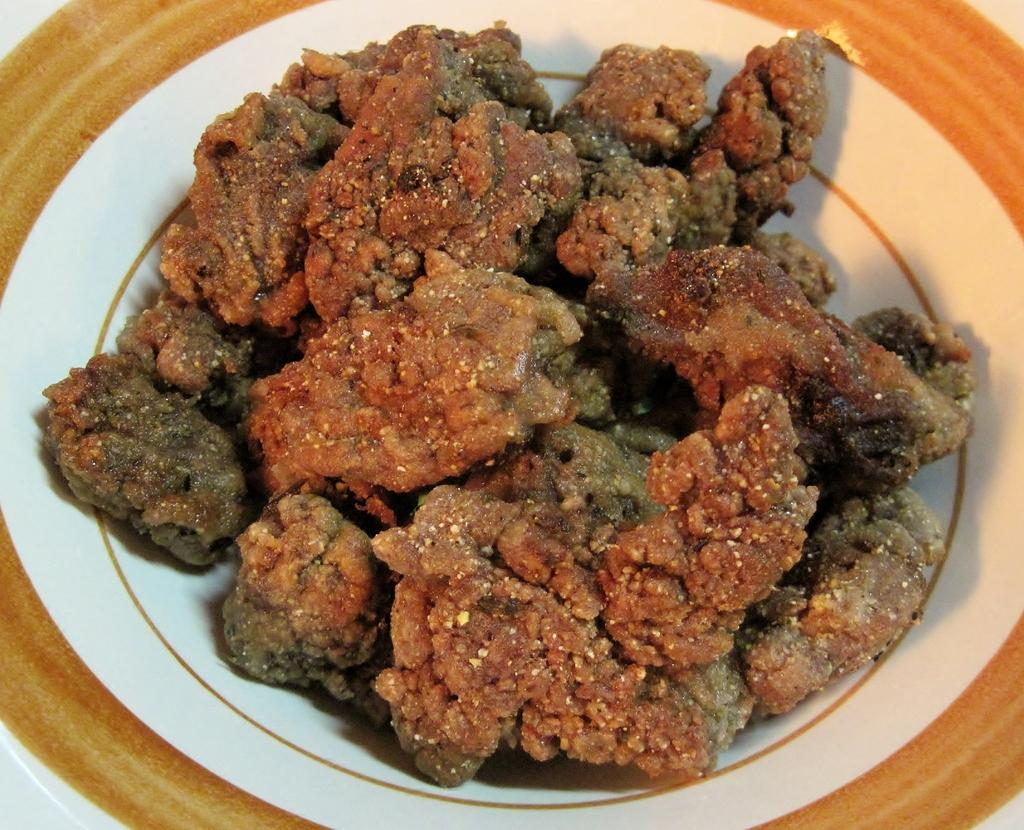What is on the plate in the image? There is food on a plate in the image. What type of yarn is being used to decorate the food on the plate? There is no yarn present in the image; it only shows food on a plate. 